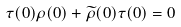<formula> <loc_0><loc_0><loc_500><loc_500>\tau ( 0 ) \rho ( 0 ) + \widetilde { \rho } ( 0 ) \tau ( 0 ) = { 0 }</formula> 